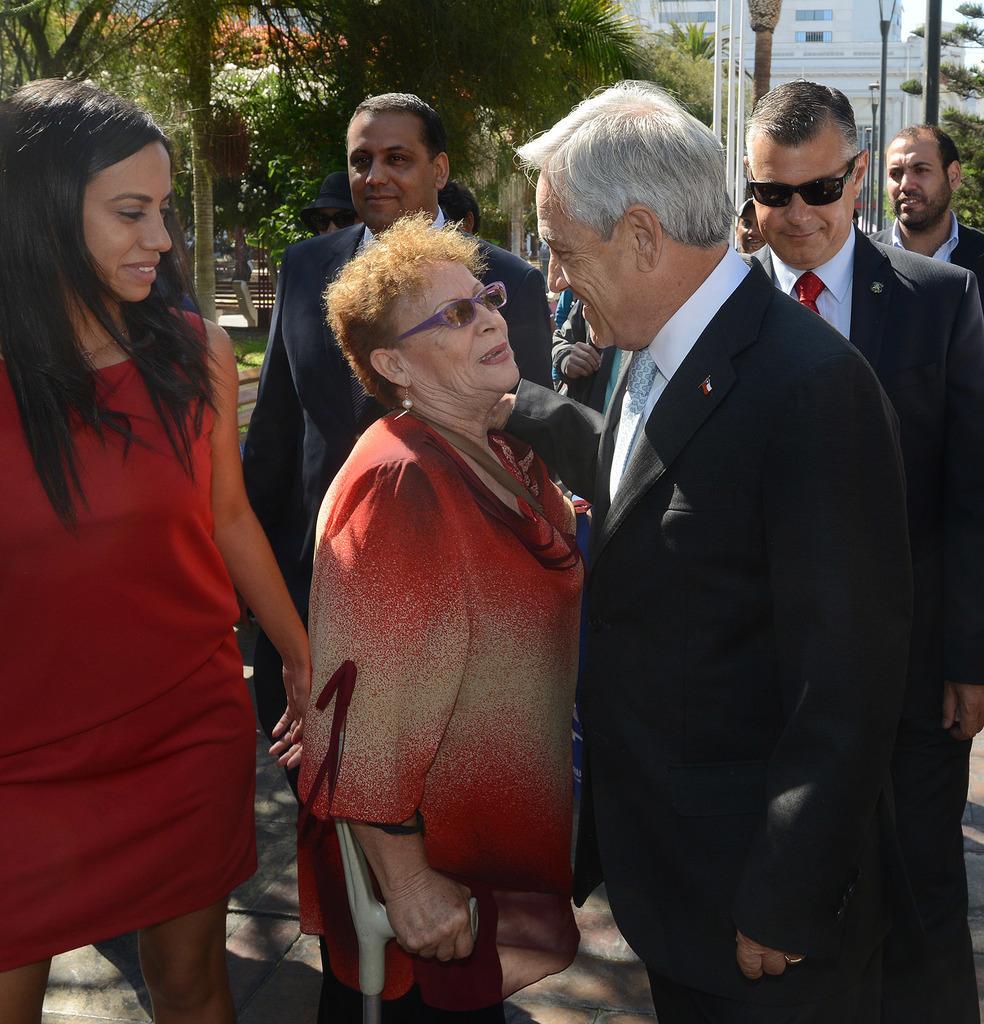Describe this image in one or two sentences. In this image we can see few persons are standing. In the background there are trees, poles, buildings, windows and objects. 